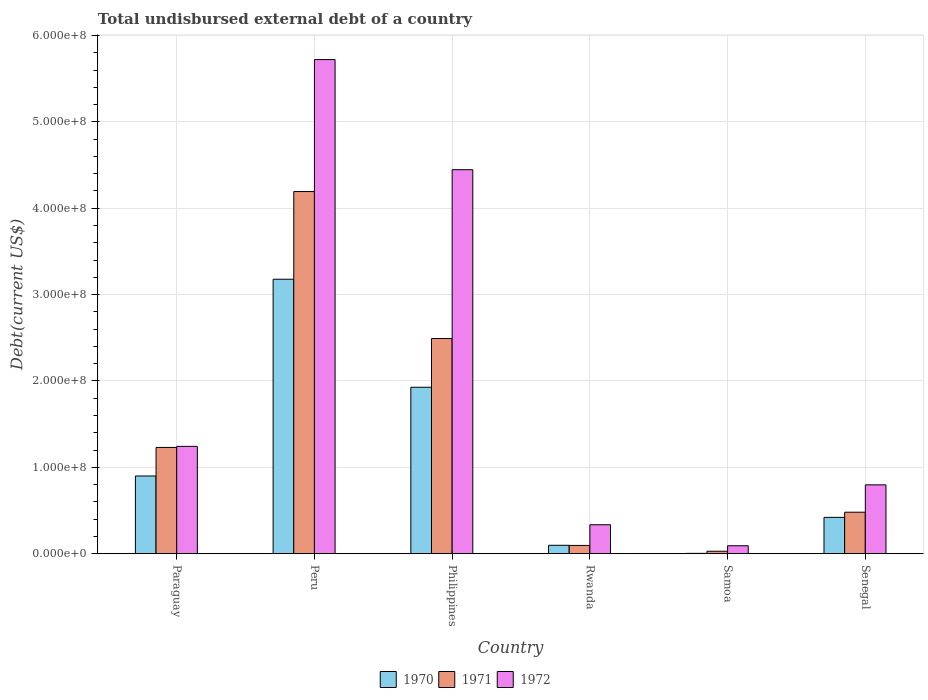How many groups of bars are there?
Offer a terse response. 6. Are the number of bars on each tick of the X-axis equal?
Your answer should be very brief. Yes. How many bars are there on the 4th tick from the left?
Offer a terse response. 3. What is the label of the 4th group of bars from the left?
Your response must be concise. Rwanda. In how many cases, is the number of bars for a given country not equal to the number of legend labels?
Ensure brevity in your answer.  0. What is the total undisbursed external debt in 1971 in Senegal?
Keep it short and to the point. 4.80e+07. Across all countries, what is the maximum total undisbursed external debt in 1970?
Your response must be concise. 3.18e+08. Across all countries, what is the minimum total undisbursed external debt in 1970?
Your response must be concise. 3.36e+05. In which country was the total undisbursed external debt in 1972 maximum?
Your answer should be very brief. Peru. In which country was the total undisbursed external debt in 1970 minimum?
Your answer should be compact. Samoa. What is the total total undisbursed external debt in 1970 in the graph?
Give a very brief answer. 6.53e+08. What is the difference between the total undisbursed external debt in 1972 in Philippines and that in Rwanda?
Offer a terse response. 4.11e+08. What is the difference between the total undisbursed external debt in 1972 in Peru and the total undisbursed external debt in 1970 in Rwanda?
Offer a very short reply. 5.62e+08. What is the average total undisbursed external debt in 1972 per country?
Give a very brief answer. 2.11e+08. What is the difference between the total undisbursed external debt of/in 1972 and total undisbursed external debt of/in 1971 in Philippines?
Your response must be concise. 1.95e+08. In how many countries, is the total undisbursed external debt in 1971 greater than 400000000 US$?
Keep it short and to the point. 1. What is the ratio of the total undisbursed external debt in 1972 in Philippines to that in Samoa?
Keep it short and to the point. 48.59. Is the total undisbursed external debt in 1971 in Peru less than that in Rwanda?
Your answer should be compact. No. What is the difference between the highest and the second highest total undisbursed external debt in 1970?
Keep it short and to the point. 2.28e+08. What is the difference between the highest and the lowest total undisbursed external debt in 1971?
Provide a short and direct response. 4.17e+08. What does the 1st bar from the right in Philippines represents?
Provide a succinct answer. 1972. How many bars are there?
Give a very brief answer. 18. Are all the bars in the graph horizontal?
Offer a very short reply. No. Does the graph contain any zero values?
Your response must be concise. No. Where does the legend appear in the graph?
Provide a succinct answer. Bottom center. What is the title of the graph?
Keep it short and to the point. Total undisbursed external debt of a country. What is the label or title of the X-axis?
Provide a succinct answer. Country. What is the label or title of the Y-axis?
Make the answer very short. Debt(current US$). What is the Debt(current US$) in 1970 in Paraguay?
Offer a very short reply. 9.00e+07. What is the Debt(current US$) of 1971 in Paraguay?
Your answer should be compact. 1.23e+08. What is the Debt(current US$) of 1972 in Paraguay?
Keep it short and to the point. 1.24e+08. What is the Debt(current US$) of 1970 in Peru?
Provide a succinct answer. 3.18e+08. What is the Debt(current US$) of 1971 in Peru?
Your answer should be very brief. 4.19e+08. What is the Debt(current US$) in 1972 in Peru?
Your answer should be very brief. 5.72e+08. What is the Debt(current US$) of 1970 in Philippines?
Your answer should be compact. 1.93e+08. What is the Debt(current US$) of 1971 in Philippines?
Make the answer very short. 2.49e+08. What is the Debt(current US$) of 1972 in Philippines?
Offer a terse response. 4.45e+08. What is the Debt(current US$) of 1970 in Rwanda?
Your answer should be very brief. 9.70e+06. What is the Debt(current US$) in 1971 in Rwanda?
Keep it short and to the point. 9.53e+06. What is the Debt(current US$) in 1972 in Rwanda?
Offer a terse response. 3.35e+07. What is the Debt(current US$) of 1970 in Samoa?
Make the answer very short. 3.36e+05. What is the Debt(current US$) of 1971 in Samoa?
Your response must be concise. 2.80e+06. What is the Debt(current US$) in 1972 in Samoa?
Your answer should be very brief. 9.15e+06. What is the Debt(current US$) of 1970 in Senegal?
Your response must be concise. 4.20e+07. What is the Debt(current US$) of 1971 in Senegal?
Your response must be concise. 4.80e+07. What is the Debt(current US$) of 1972 in Senegal?
Offer a very short reply. 7.97e+07. Across all countries, what is the maximum Debt(current US$) in 1970?
Offer a very short reply. 3.18e+08. Across all countries, what is the maximum Debt(current US$) of 1971?
Offer a very short reply. 4.19e+08. Across all countries, what is the maximum Debt(current US$) of 1972?
Offer a very short reply. 5.72e+08. Across all countries, what is the minimum Debt(current US$) in 1970?
Offer a terse response. 3.36e+05. Across all countries, what is the minimum Debt(current US$) of 1971?
Keep it short and to the point. 2.80e+06. Across all countries, what is the minimum Debt(current US$) in 1972?
Your answer should be very brief. 9.15e+06. What is the total Debt(current US$) in 1970 in the graph?
Your answer should be very brief. 6.53e+08. What is the total Debt(current US$) of 1971 in the graph?
Give a very brief answer. 8.52e+08. What is the total Debt(current US$) in 1972 in the graph?
Offer a very short reply. 1.26e+09. What is the difference between the Debt(current US$) of 1970 in Paraguay and that in Peru?
Your answer should be very brief. -2.28e+08. What is the difference between the Debt(current US$) of 1971 in Paraguay and that in Peru?
Offer a terse response. -2.96e+08. What is the difference between the Debt(current US$) of 1972 in Paraguay and that in Peru?
Your answer should be compact. -4.48e+08. What is the difference between the Debt(current US$) in 1970 in Paraguay and that in Philippines?
Your answer should be compact. -1.03e+08. What is the difference between the Debt(current US$) of 1971 in Paraguay and that in Philippines?
Make the answer very short. -1.26e+08. What is the difference between the Debt(current US$) in 1972 in Paraguay and that in Philippines?
Ensure brevity in your answer.  -3.20e+08. What is the difference between the Debt(current US$) of 1970 in Paraguay and that in Rwanda?
Your answer should be compact. 8.03e+07. What is the difference between the Debt(current US$) of 1971 in Paraguay and that in Rwanda?
Give a very brief answer. 1.13e+08. What is the difference between the Debt(current US$) of 1972 in Paraguay and that in Rwanda?
Provide a succinct answer. 9.08e+07. What is the difference between the Debt(current US$) in 1970 in Paraguay and that in Samoa?
Provide a succinct answer. 8.96e+07. What is the difference between the Debt(current US$) in 1971 in Paraguay and that in Samoa?
Keep it short and to the point. 1.20e+08. What is the difference between the Debt(current US$) of 1972 in Paraguay and that in Samoa?
Your response must be concise. 1.15e+08. What is the difference between the Debt(current US$) in 1970 in Paraguay and that in Senegal?
Your answer should be very brief. 4.79e+07. What is the difference between the Debt(current US$) in 1971 in Paraguay and that in Senegal?
Provide a short and direct response. 7.50e+07. What is the difference between the Debt(current US$) in 1972 in Paraguay and that in Senegal?
Offer a terse response. 4.46e+07. What is the difference between the Debt(current US$) of 1970 in Peru and that in Philippines?
Offer a terse response. 1.25e+08. What is the difference between the Debt(current US$) in 1971 in Peru and that in Philippines?
Offer a terse response. 1.70e+08. What is the difference between the Debt(current US$) of 1972 in Peru and that in Philippines?
Your response must be concise. 1.28e+08. What is the difference between the Debt(current US$) of 1970 in Peru and that in Rwanda?
Your answer should be very brief. 3.08e+08. What is the difference between the Debt(current US$) of 1971 in Peru and that in Rwanda?
Ensure brevity in your answer.  4.10e+08. What is the difference between the Debt(current US$) in 1972 in Peru and that in Rwanda?
Provide a succinct answer. 5.39e+08. What is the difference between the Debt(current US$) of 1970 in Peru and that in Samoa?
Your response must be concise. 3.17e+08. What is the difference between the Debt(current US$) in 1971 in Peru and that in Samoa?
Keep it short and to the point. 4.17e+08. What is the difference between the Debt(current US$) of 1972 in Peru and that in Samoa?
Make the answer very short. 5.63e+08. What is the difference between the Debt(current US$) of 1970 in Peru and that in Senegal?
Your response must be concise. 2.76e+08. What is the difference between the Debt(current US$) in 1971 in Peru and that in Senegal?
Make the answer very short. 3.71e+08. What is the difference between the Debt(current US$) of 1972 in Peru and that in Senegal?
Offer a very short reply. 4.92e+08. What is the difference between the Debt(current US$) in 1970 in Philippines and that in Rwanda?
Your answer should be very brief. 1.83e+08. What is the difference between the Debt(current US$) in 1971 in Philippines and that in Rwanda?
Offer a terse response. 2.40e+08. What is the difference between the Debt(current US$) in 1972 in Philippines and that in Rwanda?
Ensure brevity in your answer.  4.11e+08. What is the difference between the Debt(current US$) in 1970 in Philippines and that in Samoa?
Keep it short and to the point. 1.92e+08. What is the difference between the Debt(current US$) of 1971 in Philippines and that in Samoa?
Provide a short and direct response. 2.46e+08. What is the difference between the Debt(current US$) in 1972 in Philippines and that in Samoa?
Your response must be concise. 4.35e+08. What is the difference between the Debt(current US$) of 1970 in Philippines and that in Senegal?
Offer a terse response. 1.51e+08. What is the difference between the Debt(current US$) of 1971 in Philippines and that in Senegal?
Your answer should be compact. 2.01e+08. What is the difference between the Debt(current US$) of 1972 in Philippines and that in Senegal?
Provide a succinct answer. 3.65e+08. What is the difference between the Debt(current US$) of 1970 in Rwanda and that in Samoa?
Make the answer very short. 9.36e+06. What is the difference between the Debt(current US$) in 1971 in Rwanda and that in Samoa?
Your answer should be compact. 6.73e+06. What is the difference between the Debt(current US$) in 1972 in Rwanda and that in Samoa?
Your response must be concise. 2.43e+07. What is the difference between the Debt(current US$) in 1970 in Rwanda and that in Senegal?
Offer a terse response. -3.23e+07. What is the difference between the Debt(current US$) of 1971 in Rwanda and that in Senegal?
Provide a succinct answer. -3.85e+07. What is the difference between the Debt(current US$) of 1972 in Rwanda and that in Senegal?
Give a very brief answer. -4.62e+07. What is the difference between the Debt(current US$) in 1970 in Samoa and that in Senegal?
Provide a short and direct response. -4.17e+07. What is the difference between the Debt(current US$) in 1971 in Samoa and that in Senegal?
Give a very brief answer. -4.52e+07. What is the difference between the Debt(current US$) in 1972 in Samoa and that in Senegal?
Give a very brief answer. -7.05e+07. What is the difference between the Debt(current US$) in 1970 in Paraguay and the Debt(current US$) in 1971 in Peru?
Your response must be concise. -3.29e+08. What is the difference between the Debt(current US$) of 1970 in Paraguay and the Debt(current US$) of 1972 in Peru?
Offer a very short reply. -4.82e+08. What is the difference between the Debt(current US$) of 1971 in Paraguay and the Debt(current US$) of 1972 in Peru?
Your answer should be compact. -4.49e+08. What is the difference between the Debt(current US$) of 1970 in Paraguay and the Debt(current US$) of 1971 in Philippines?
Your response must be concise. -1.59e+08. What is the difference between the Debt(current US$) of 1970 in Paraguay and the Debt(current US$) of 1972 in Philippines?
Give a very brief answer. -3.55e+08. What is the difference between the Debt(current US$) of 1971 in Paraguay and the Debt(current US$) of 1972 in Philippines?
Give a very brief answer. -3.22e+08. What is the difference between the Debt(current US$) in 1970 in Paraguay and the Debt(current US$) in 1971 in Rwanda?
Offer a very short reply. 8.04e+07. What is the difference between the Debt(current US$) of 1970 in Paraguay and the Debt(current US$) of 1972 in Rwanda?
Give a very brief answer. 5.65e+07. What is the difference between the Debt(current US$) of 1971 in Paraguay and the Debt(current US$) of 1972 in Rwanda?
Make the answer very short. 8.95e+07. What is the difference between the Debt(current US$) of 1970 in Paraguay and the Debt(current US$) of 1971 in Samoa?
Ensure brevity in your answer.  8.72e+07. What is the difference between the Debt(current US$) of 1970 in Paraguay and the Debt(current US$) of 1972 in Samoa?
Offer a terse response. 8.08e+07. What is the difference between the Debt(current US$) of 1971 in Paraguay and the Debt(current US$) of 1972 in Samoa?
Offer a terse response. 1.14e+08. What is the difference between the Debt(current US$) of 1970 in Paraguay and the Debt(current US$) of 1971 in Senegal?
Your answer should be compact. 4.20e+07. What is the difference between the Debt(current US$) of 1970 in Paraguay and the Debt(current US$) of 1972 in Senegal?
Provide a short and direct response. 1.03e+07. What is the difference between the Debt(current US$) of 1971 in Paraguay and the Debt(current US$) of 1972 in Senegal?
Ensure brevity in your answer.  4.33e+07. What is the difference between the Debt(current US$) in 1970 in Peru and the Debt(current US$) in 1971 in Philippines?
Offer a very short reply. 6.86e+07. What is the difference between the Debt(current US$) of 1970 in Peru and the Debt(current US$) of 1972 in Philippines?
Your answer should be very brief. -1.27e+08. What is the difference between the Debt(current US$) in 1971 in Peru and the Debt(current US$) in 1972 in Philippines?
Make the answer very short. -2.53e+07. What is the difference between the Debt(current US$) of 1970 in Peru and the Debt(current US$) of 1971 in Rwanda?
Provide a succinct answer. 3.08e+08. What is the difference between the Debt(current US$) in 1970 in Peru and the Debt(current US$) in 1972 in Rwanda?
Provide a succinct answer. 2.84e+08. What is the difference between the Debt(current US$) in 1971 in Peru and the Debt(current US$) in 1972 in Rwanda?
Keep it short and to the point. 3.86e+08. What is the difference between the Debt(current US$) of 1970 in Peru and the Debt(current US$) of 1971 in Samoa?
Ensure brevity in your answer.  3.15e+08. What is the difference between the Debt(current US$) in 1970 in Peru and the Debt(current US$) in 1972 in Samoa?
Your answer should be very brief. 3.09e+08. What is the difference between the Debt(current US$) in 1971 in Peru and the Debt(current US$) in 1972 in Samoa?
Provide a short and direct response. 4.10e+08. What is the difference between the Debt(current US$) of 1970 in Peru and the Debt(current US$) of 1971 in Senegal?
Your answer should be very brief. 2.70e+08. What is the difference between the Debt(current US$) of 1970 in Peru and the Debt(current US$) of 1972 in Senegal?
Offer a very short reply. 2.38e+08. What is the difference between the Debt(current US$) in 1971 in Peru and the Debt(current US$) in 1972 in Senegal?
Give a very brief answer. 3.40e+08. What is the difference between the Debt(current US$) of 1970 in Philippines and the Debt(current US$) of 1971 in Rwanda?
Offer a very short reply. 1.83e+08. What is the difference between the Debt(current US$) in 1970 in Philippines and the Debt(current US$) in 1972 in Rwanda?
Give a very brief answer. 1.59e+08. What is the difference between the Debt(current US$) in 1971 in Philippines and the Debt(current US$) in 1972 in Rwanda?
Keep it short and to the point. 2.16e+08. What is the difference between the Debt(current US$) of 1970 in Philippines and the Debt(current US$) of 1971 in Samoa?
Your answer should be very brief. 1.90e+08. What is the difference between the Debt(current US$) of 1970 in Philippines and the Debt(current US$) of 1972 in Samoa?
Offer a terse response. 1.84e+08. What is the difference between the Debt(current US$) in 1971 in Philippines and the Debt(current US$) in 1972 in Samoa?
Offer a very short reply. 2.40e+08. What is the difference between the Debt(current US$) of 1970 in Philippines and the Debt(current US$) of 1971 in Senegal?
Provide a short and direct response. 1.45e+08. What is the difference between the Debt(current US$) of 1970 in Philippines and the Debt(current US$) of 1972 in Senegal?
Keep it short and to the point. 1.13e+08. What is the difference between the Debt(current US$) in 1971 in Philippines and the Debt(current US$) in 1972 in Senegal?
Ensure brevity in your answer.  1.69e+08. What is the difference between the Debt(current US$) in 1970 in Rwanda and the Debt(current US$) in 1971 in Samoa?
Ensure brevity in your answer.  6.90e+06. What is the difference between the Debt(current US$) in 1970 in Rwanda and the Debt(current US$) in 1972 in Samoa?
Your response must be concise. 5.45e+05. What is the difference between the Debt(current US$) in 1971 in Rwanda and the Debt(current US$) in 1972 in Samoa?
Your answer should be compact. 3.82e+05. What is the difference between the Debt(current US$) of 1970 in Rwanda and the Debt(current US$) of 1971 in Senegal?
Ensure brevity in your answer.  -3.83e+07. What is the difference between the Debt(current US$) of 1970 in Rwanda and the Debt(current US$) of 1972 in Senegal?
Your response must be concise. -7.00e+07. What is the difference between the Debt(current US$) of 1971 in Rwanda and the Debt(current US$) of 1972 in Senegal?
Provide a succinct answer. -7.02e+07. What is the difference between the Debt(current US$) in 1970 in Samoa and the Debt(current US$) in 1971 in Senegal?
Offer a very short reply. -4.77e+07. What is the difference between the Debt(current US$) of 1970 in Samoa and the Debt(current US$) of 1972 in Senegal?
Keep it short and to the point. -7.93e+07. What is the difference between the Debt(current US$) of 1971 in Samoa and the Debt(current US$) of 1972 in Senegal?
Ensure brevity in your answer.  -7.69e+07. What is the average Debt(current US$) of 1970 per country?
Provide a succinct answer. 1.09e+08. What is the average Debt(current US$) in 1971 per country?
Make the answer very short. 1.42e+08. What is the average Debt(current US$) in 1972 per country?
Ensure brevity in your answer.  2.11e+08. What is the difference between the Debt(current US$) of 1970 and Debt(current US$) of 1971 in Paraguay?
Give a very brief answer. -3.31e+07. What is the difference between the Debt(current US$) in 1970 and Debt(current US$) in 1972 in Paraguay?
Your answer should be very brief. -3.43e+07. What is the difference between the Debt(current US$) in 1971 and Debt(current US$) in 1972 in Paraguay?
Offer a terse response. -1.22e+06. What is the difference between the Debt(current US$) of 1970 and Debt(current US$) of 1971 in Peru?
Provide a short and direct response. -1.02e+08. What is the difference between the Debt(current US$) of 1970 and Debt(current US$) of 1972 in Peru?
Keep it short and to the point. -2.54e+08. What is the difference between the Debt(current US$) of 1971 and Debt(current US$) of 1972 in Peru?
Make the answer very short. -1.53e+08. What is the difference between the Debt(current US$) of 1970 and Debt(current US$) of 1971 in Philippines?
Offer a very short reply. -5.64e+07. What is the difference between the Debt(current US$) in 1970 and Debt(current US$) in 1972 in Philippines?
Keep it short and to the point. -2.52e+08. What is the difference between the Debt(current US$) of 1971 and Debt(current US$) of 1972 in Philippines?
Provide a succinct answer. -1.95e+08. What is the difference between the Debt(current US$) in 1970 and Debt(current US$) in 1971 in Rwanda?
Offer a terse response. 1.63e+05. What is the difference between the Debt(current US$) in 1970 and Debt(current US$) in 1972 in Rwanda?
Your response must be concise. -2.38e+07. What is the difference between the Debt(current US$) of 1971 and Debt(current US$) of 1972 in Rwanda?
Give a very brief answer. -2.40e+07. What is the difference between the Debt(current US$) of 1970 and Debt(current US$) of 1971 in Samoa?
Keep it short and to the point. -2.46e+06. What is the difference between the Debt(current US$) of 1970 and Debt(current US$) of 1972 in Samoa?
Offer a terse response. -8.82e+06. What is the difference between the Debt(current US$) of 1971 and Debt(current US$) of 1972 in Samoa?
Your answer should be compact. -6.35e+06. What is the difference between the Debt(current US$) in 1970 and Debt(current US$) in 1971 in Senegal?
Your answer should be compact. -5.97e+06. What is the difference between the Debt(current US$) in 1970 and Debt(current US$) in 1972 in Senegal?
Give a very brief answer. -3.77e+07. What is the difference between the Debt(current US$) in 1971 and Debt(current US$) in 1972 in Senegal?
Make the answer very short. -3.17e+07. What is the ratio of the Debt(current US$) in 1970 in Paraguay to that in Peru?
Offer a terse response. 0.28. What is the ratio of the Debt(current US$) in 1971 in Paraguay to that in Peru?
Ensure brevity in your answer.  0.29. What is the ratio of the Debt(current US$) in 1972 in Paraguay to that in Peru?
Offer a terse response. 0.22. What is the ratio of the Debt(current US$) of 1970 in Paraguay to that in Philippines?
Your answer should be compact. 0.47. What is the ratio of the Debt(current US$) in 1971 in Paraguay to that in Philippines?
Your answer should be very brief. 0.49. What is the ratio of the Debt(current US$) in 1972 in Paraguay to that in Philippines?
Give a very brief answer. 0.28. What is the ratio of the Debt(current US$) in 1970 in Paraguay to that in Rwanda?
Provide a short and direct response. 9.28. What is the ratio of the Debt(current US$) in 1971 in Paraguay to that in Rwanda?
Ensure brevity in your answer.  12.91. What is the ratio of the Debt(current US$) of 1972 in Paraguay to that in Rwanda?
Provide a succinct answer. 3.71. What is the ratio of the Debt(current US$) in 1970 in Paraguay to that in Samoa?
Provide a succinct answer. 267.74. What is the ratio of the Debt(current US$) of 1971 in Paraguay to that in Samoa?
Make the answer very short. 43.92. What is the ratio of the Debt(current US$) in 1972 in Paraguay to that in Samoa?
Offer a terse response. 13.58. What is the ratio of the Debt(current US$) of 1970 in Paraguay to that in Senegal?
Your response must be concise. 2.14. What is the ratio of the Debt(current US$) in 1971 in Paraguay to that in Senegal?
Offer a terse response. 2.56. What is the ratio of the Debt(current US$) of 1972 in Paraguay to that in Senegal?
Offer a very short reply. 1.56. What is the ratio of the Debt(current US$) in 1970 in Peru to that in Philippines?
Your answer should be compact. 1.65. What is the ratio of the Debt(current US$) in 1971 in Peru to that in Philippines?
Your answer should be compact. 1.68. What is the ratio of the Debt(current US$) of 1972 in Peru to that in Philippines?
Your response must be concise. 1.29. What is the ratio of the Debt(current US$) in 1970 in Peru to that in Rwanda?
Offer a terse response. 32.78. What is the ratio of the Debt(current US$) of 1971 in Peru to that in Rwanda?
Keep it short and to the point. 43.99. What is the ratio of the Debt(current US$) in 1972 in Peru to that in Rwanda?
Provide a succinct answer. 17.08. What is the ratio of the Debt(current US$) of 1970 in Peru to that in Samoa?
Offer a very short reply. 945.85. What is the ratio of the Debt(current US$) of 1971 in Peru to that in Samoa?
Give a very brief answer. 149.71. What is the ratio of the Debt(current US$) in 1972 in Peru to that in Samoa?
Offer a very short reply. 62.53. What is the ratio of the Debt(current US$) of 1970 in Peru to that in Senegal?
Offer a terse response. 7.56. What is the ratio of the Debt(current US$) of 1971 in Peru to that in Senegal?
Make the answer very short. 8.74. What is the ratio of the Debt(current US$) in 1972 in Peru to that in Senegal?
Provide a succinct answer. 7.18. What is the ratio of the Debt(current US$) in 1970 in Philippines to that in Rwanda?
Make the answer very short. 19.88. What is the ratio of the Debt(current US$) of 1971 in Philippines to that in Rwanda?
Make the answer very short. 26.14. What is the ratio of the Debt(current US$) of 1972 in Philippines to that in Rwanda?
Ensure brevity in your answer.  13.28. What is the ratio of the Debt(current US$) of 1970 in Philippines to that in Samoa?
Your answer should be very brief. 573.59. What is the ratio of the Debt(current US$) in 1971 in Philippines to that in Samoa?
Offer a very short reply. 88.95. What is the ratio of the Debt(current US$) in 1972 in Philippines to that in Samoa?
Offer a very short reply. 48.59. What is the ratio of the Debt(current US$) of 1970 in Philippines to that in Senegal?
Offer a very short reply. 4.59. What is the ratio of the Debt(current US$) of 1971 in Philippines to that in Senegal?
Give a very brief answer. 5.19. What is the ratio of the Debt(current US$) in 1972 in Philippines to that in Senegal?
Provide a succinct answer. 5.58. What is the ratio of the Debt(current US$) of 1970 in Rwanda to that in Samoa?
Offer a very short reply. 28.86. What is the ratio of the Debt(current US$) in 1971 in Rwanda to that in Samoa?
Ensure brevity in your answer.  3.4. What is the ratio of the Debt(current US$) in 1972 in Rwanda to that in Samoa?
Keep it short and to the point. 3.66. What is the ratio of the Debt(current US$) of 1970 in Rwanda to that in Senegal?
Offer a very short reply. 0.23. What is the ratio of the Debt(current US$) of 1971 in Rwanda to that in Senegal?
Your response must be concise. 0.2. What is the ratio of the Debt(current US$) in 1972 in Rwanda to that in Senegal?
Your answer should be compact. 0.42. What is the ratio of the Debt(current US$) of 1970 in Samoa to that in Senegal?
Give a very brief answer. 0.01. What is the ratio of the Debt(current US$) in 1971 in Samoa to that in Senegal?
Offer a terse response. 0.06. What is the ratio of the Debt(current US$) in 1972 in Samoa to that in Senegal?
Your answer should be very brief. 0.11. What is the difference between the highest and the second highest Debt(current US$) of 1970?
Provide a succinct answer. 1.25e+08. What is the difference between the highest and the second highest Debt(current US$) of 1971?
Provide a succinct answer. 1.70e+08. What is the difference between the highest and the second highest Debt(current US$) in 1972?
Offer a terse response. 1.28e+08. What is the difference between the highest and the lowest Debt(current US$) of 1970?
Your answer should be very brief. 3.17e+08. What is the difference between the highest and the lowest Debt(current US$) of 1971?
Your answer should be very brief. 4.17e+08. What is the difference between the highest and the lowest Debt(current US$) of 1972?
Provide a succinct answer. 5.63e+08. 